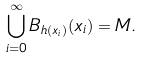<formula> <loc_0><loc_0><loc_500><loc_500>\bigcup _ { i = 0 } ^ { \infty } B _ { h ( x _ { i } ) } ( x _ { i } ) = M .</formula> 